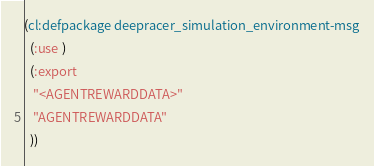<code> <loc_0><loc_0><loc_500><loc_500><_Lisp_>(cl:defpackage deepracer_simulation_environment-msg
  (:use )
  (:export
   "<AGENTREWARDDATA>"
   "AGENTREWARDDATA"
  ))

</code> 